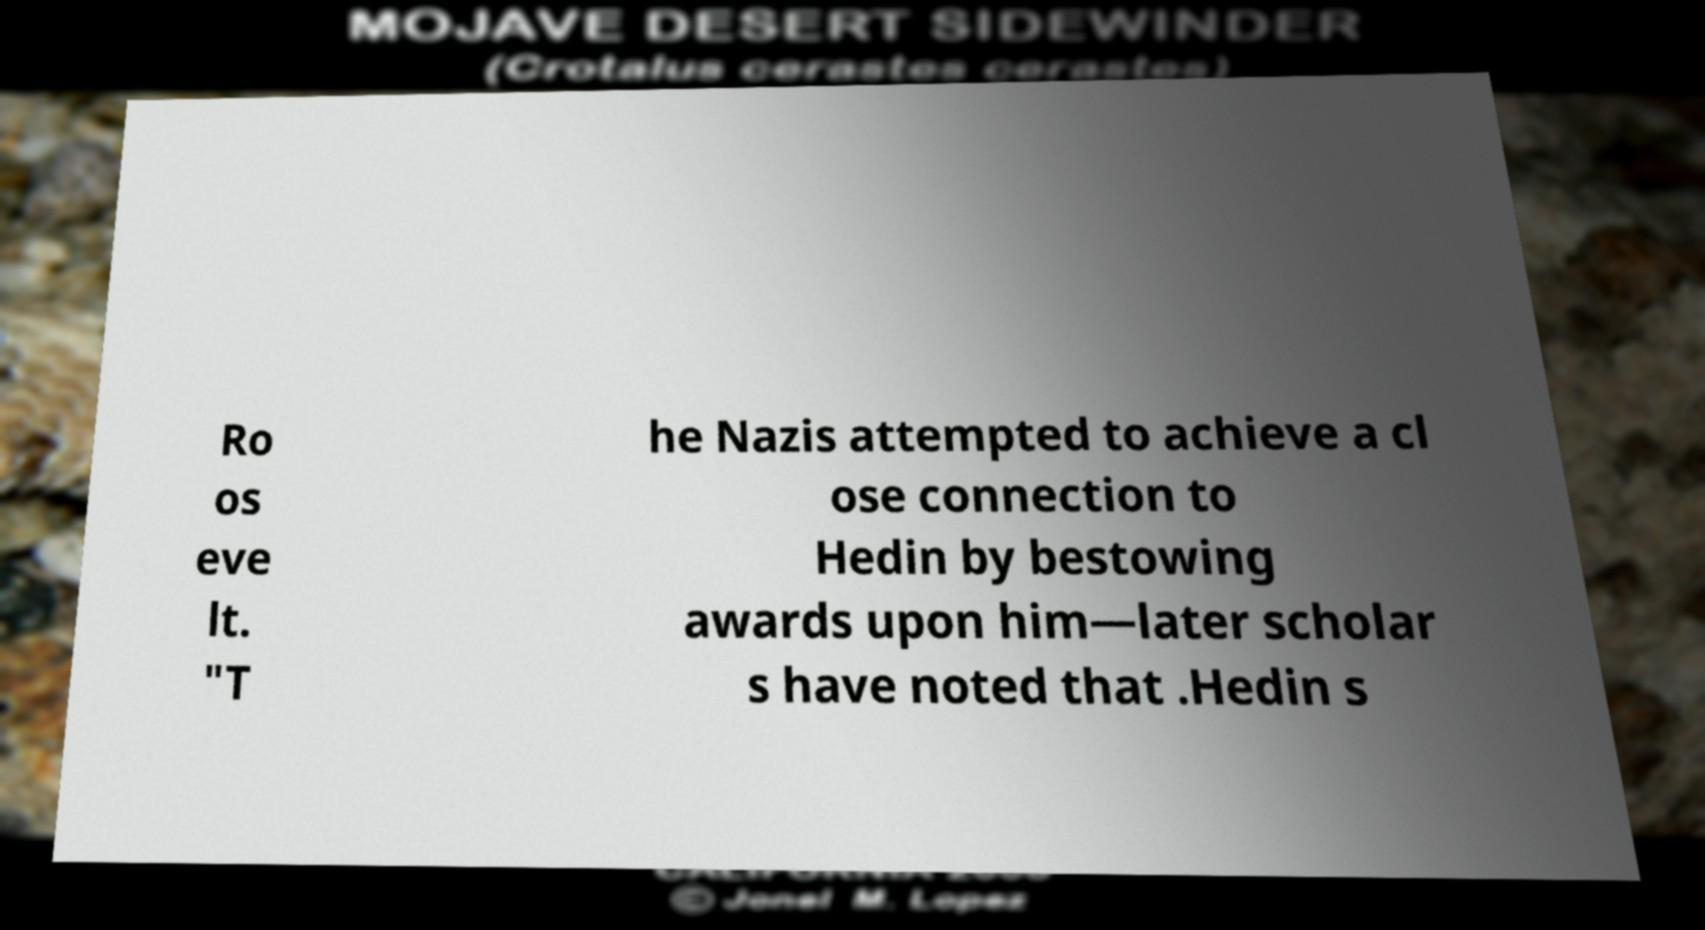Please read and relay the text visible in this image. What does it say? Ro os eve lt. "T he Nazis attempted to achieve a cl ose connection to Hedin by bestowing awards upon him—later scholar s have noted that .Hedin s 